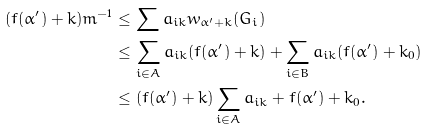Convert formula to latex. <formula><loc_0><loc_0><loc_500><loc_500>( f ( \alpha ^ { \prime } ) + k ) m ^ { - 1 } & \leq \sum a _ { i k } w _ { \alpha ^ { \prime } + k } ( G _ { i } ) \\ & \leq \sum _ { i \in A } a _ { i k } ( f ( \alpha ^ { \prime } ) + k ) + \sum _ { i \in B } a _ { i k } ( f ( \alpha ^ { \prime } ) + k _ { 0 } ) \\ & \leq ( f ( \alpha ^ { \prime } ) + k ) \sum _ { i \in A } a _ { i k } + f ( \alpha ^ { \prime } ) + k _ { 0 } .</formula> 